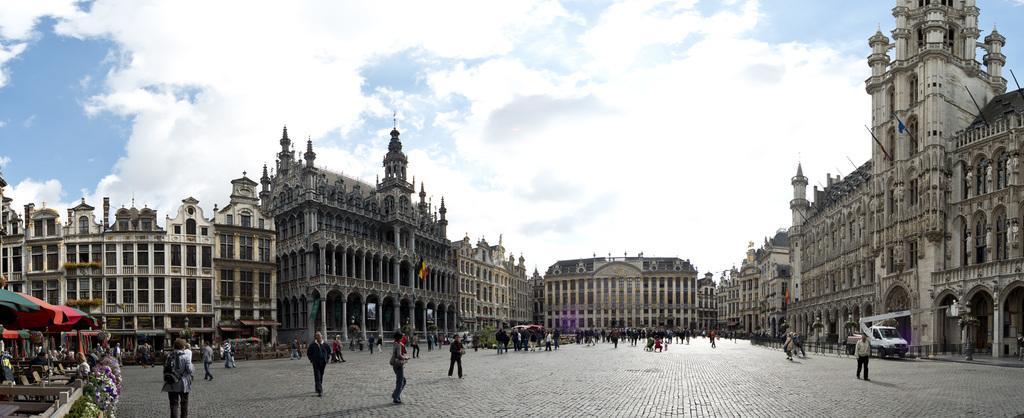How would you summarize this image in a sentence or two? These are the buildings with the windows. I can see groups of people walking. This looks like a van with a crane on it. At the bottom left side of the image, I think these are the kind of patio umbrellas. These are the plants with the flowers. This is the sky. I think this is a flag, which is hanging to a pole. 